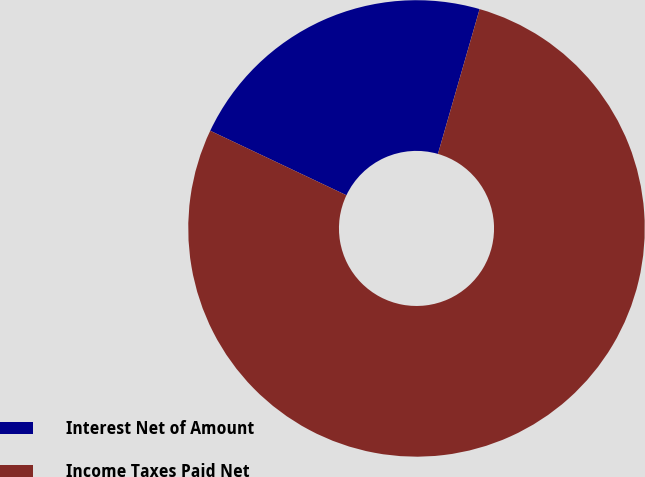Convert chart. <chart><loc_0><loc_0><loc_500><loc_500><pie_chart><fcel>Interest Net of Amount<fcel>Income Taxes Paid Net<nl><fcel>22.42%<fcel>77.58%<nl></chart> 